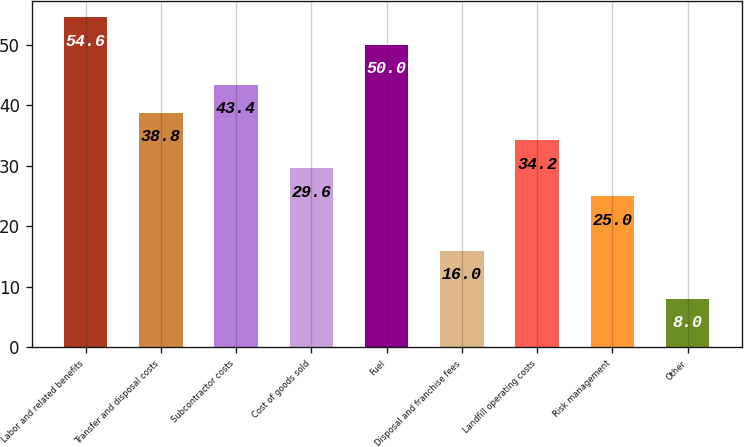<chart> <loc_0><loc_0><loc_500><loc_500><bar_chart><fcel>Labor and related benefits<fcel>Transfer and disposal costs<fcel>Subcontractor costs<fcel>Cost of goods sold<fcel>Fuel<fcel>Disposal and franchise fees<fcel>Landfill operating costs<fcel>Risk management<fcel>Other<nl><fcel>54.6<fcel>38.8<fcel>43.4<fcel>29.6<fcel>50<fcel>16<fcel>34.2<fcel>25<fcel>8<nl></chart> 